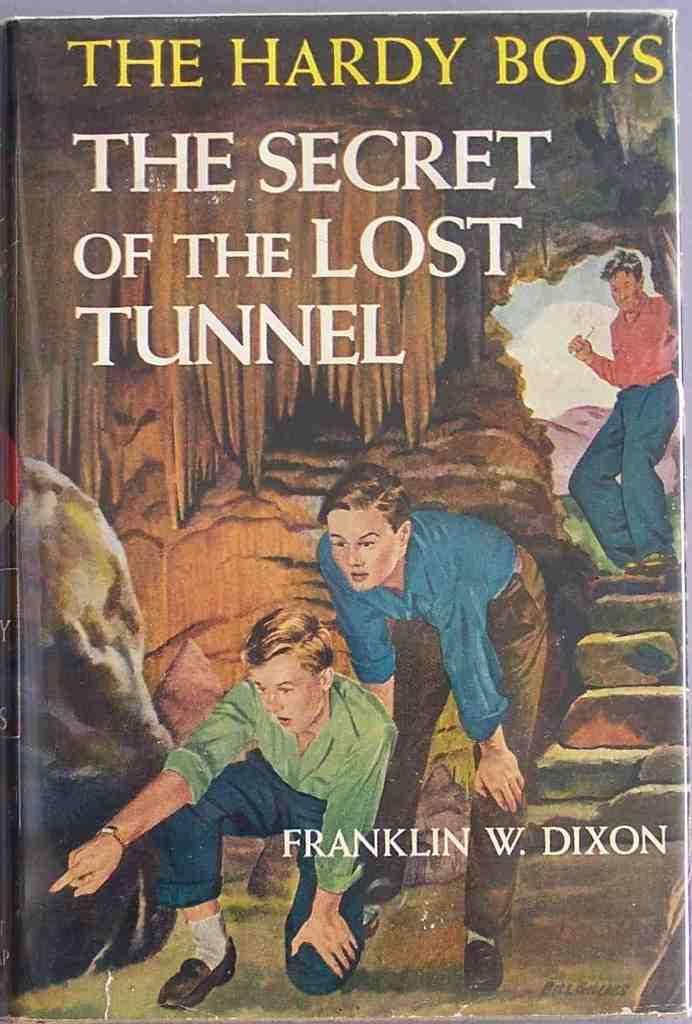<image>
Create a compact narrative representing the image presented. A book cover titled The Hardy Boys The Secret of the Lost Tunnel. 